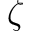<formula> <loc_0><loc_0><loc_500><loc_500>\zeta</formula> 